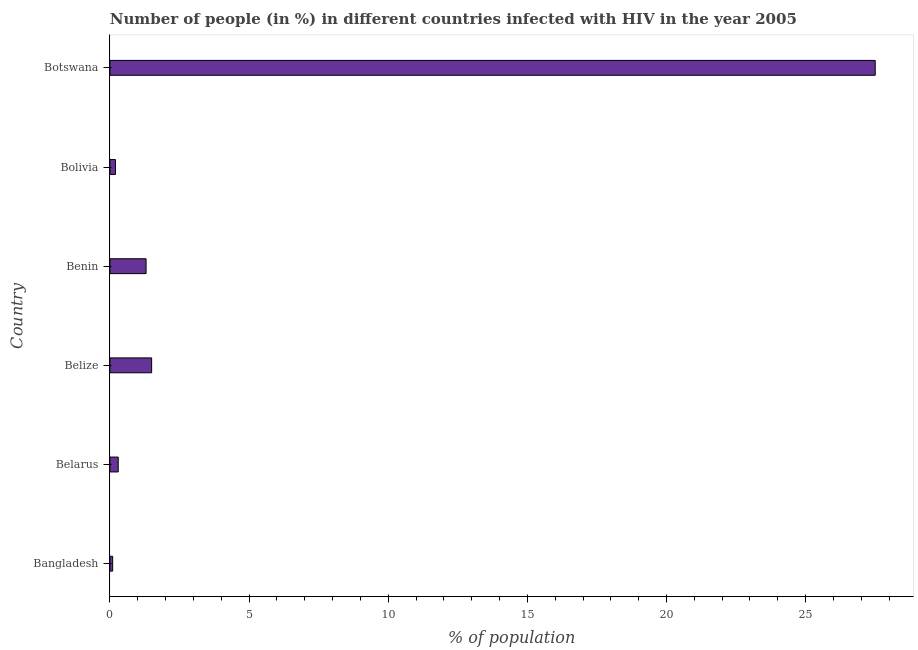What is the title of the graph?
Make the answer very short. Number of people (in %) in different countries infected with HIV in the year 2005. What is the label or title of the X-axis?
Ensure brevity in your answer.  % of population. Across all countries, what is the minimum number of people infected with hiv?
Keep it short and to the point. 0.1. In which country was the number of people infected with hiv maximum?
Provide a succinct answer. Botswana. What is the sum of the number of people infected with hiv?
Provide a succinct answer. 30.9. What is the average number of people infected with hiv per country?
Give a very brief answer. 5.15. What is the ratio of the number of people infected with hiv in Belize to that in Bolivia?
Give a very brief answer. 7.5. Is the number of people infected with hiv in Benin less than that in Bolivia?
Provide a succinct answer. No. What is the difference between the highest and the lowest number of people infected with hiv?
Provide a succinct answer. 27.4. In how many countries, is the number of people infected with hiv greater than the average number of people infected with hiv taken over all countries?
Offer a terse response. 1. How many bars are there?
Provide a succinct answer. 6. How many countries are there in the graph?
Offer a very short reply. 6. Are the values on the major ticks of X-axis written in scientific E-notation?
Your answer should be compact. No. What is the % of population of Belize?
Offer a terse response. 1.5. What is the % of population in Benin?
Provide a short and direct response. 1.3. What is the % of population in Botswana?
Provide a short and direct response. 27.5. What is the difference between the % of population in Bangladesh and Belarus?
Your answer should be very brief. -0.2. What is the difference between the % of population in Bangladesh and Benin?
Offer a very short reply. -1.2. What is the difference between the % of population in Bangladesh and Botswana?
Offer a very short reply. -27.4. What is the difference between the % of population in Belarus and Benin?
Your answer should be compact. -1. What is the difference between the % of population in Belarus and Botswana?
Make the answer very short. -27.2. What is the difference between the % of population in Belize and Benin?
Give a very brief answer. 0.2. What is the difference between the % of population in Belize and Bolivia?
Give a very brief answer. 1.3. What is the difference between the % of population in Belize and Botswana?
Offer a terse response. -26. What is the difference between the % of population in Benin and Bolivia?
Give a very brief answer. 1.1. What is the difference between the % of population in Benin and Botswana?
Your response must be concise. -26.2. What is the difference between the % of population in Bolivia and Botswana?
Provide a succinct answer. -27.3. What is the ratio of the % of population in Bangladesh to that in Belarus?
Your answer should be very brief. 0.33. What is the ratio of the % of population in Bangladesh to that in Belize?
Your answer should be very brief. 0.07. What is the ratio of the % of population in Bangladesh to that in Benin?
Your answer should be very brief. 0.08. What is the ratio of the % of population in Bangladesh to that in Botswana?
Your answer should be very brief. 0. What is the ratio of the % of population in Belarus to that in Benin?
Your answer should be very brief. 0.23. What is the ratio of the % of population in Belarus to that in Bolivia?
Provide a succinct answer. 1.5. What is the ratio of the % of population in Belarus to that in Botswana?
Your answer should be very brief. 0.01. What is the ratio of the % of population in Belize to that in Benin?
Provide a short and direct response. 1.15. What is the ratio of the % of population in Belize to that in Bolivia?
Your answer should be compact. 7.5. What is the ratio of the % of population in Belize to that in Botswana?
Provide a succinct answer. 0.06. What is the ratio of the % of population in Benin to that in Botswana?
Your answer should be compact. 0.05. What is the ratio of the % of population in Bolivia to that in Botswana?
Your answer should be very brief. 0.01. 